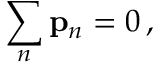Convert formula to latex. <formula><loc_0><loc_0><loc_500><loc_500>\sum _ { n } p _ { n } = { 0 } \, ,</formula> 